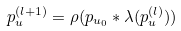Convert formula to latex. <formula><loc_0><loc_0><loc_500><loc_500>p _ { u } ^ { ( l + 1 ) } = \rho ( p _ { u _ { 0 } } \ast \lambda ( p _ { u } ^ { ( l ) } ) )</formula> 